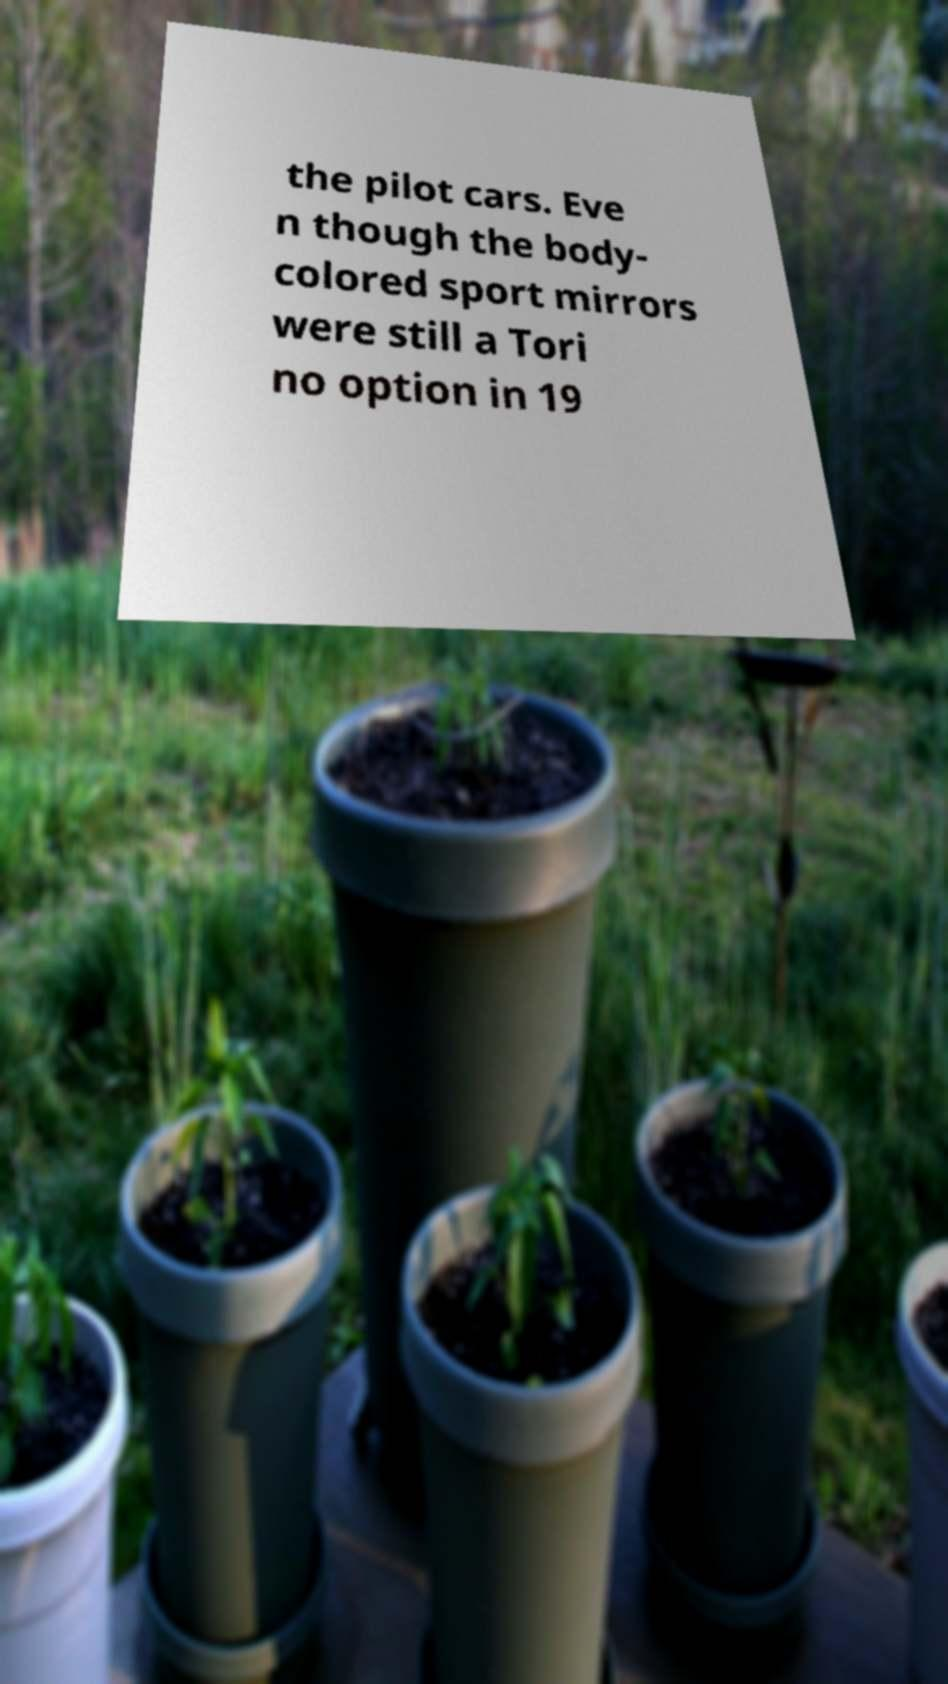I need the written content from this picture converted into text. Can you do that? the pilot cars. Eve n though the body- colored sport mirrors were still a Tori no option in 19 